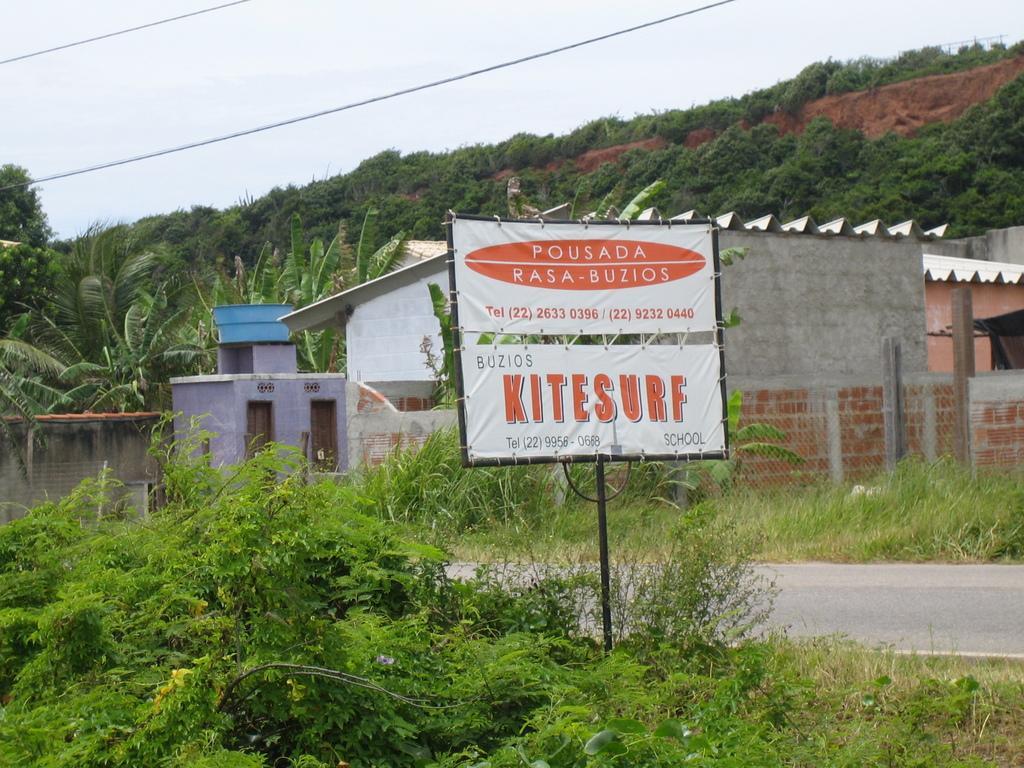In one or two sentences, can you explain what this image depicts? In this image I can see I can see road, a white color board, buildings, grass, trees, sky and wires. Here on this board I can see something is written. 